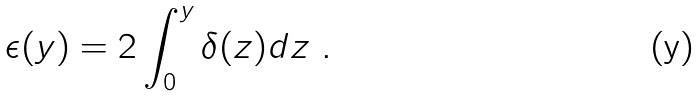<formula> <loc_0><loc_0><loc_500><loc_500>\epsilon ( y ) = 2 \int _ { 0 } ^ { y } \delta ( z ) d z \ .</formula> 